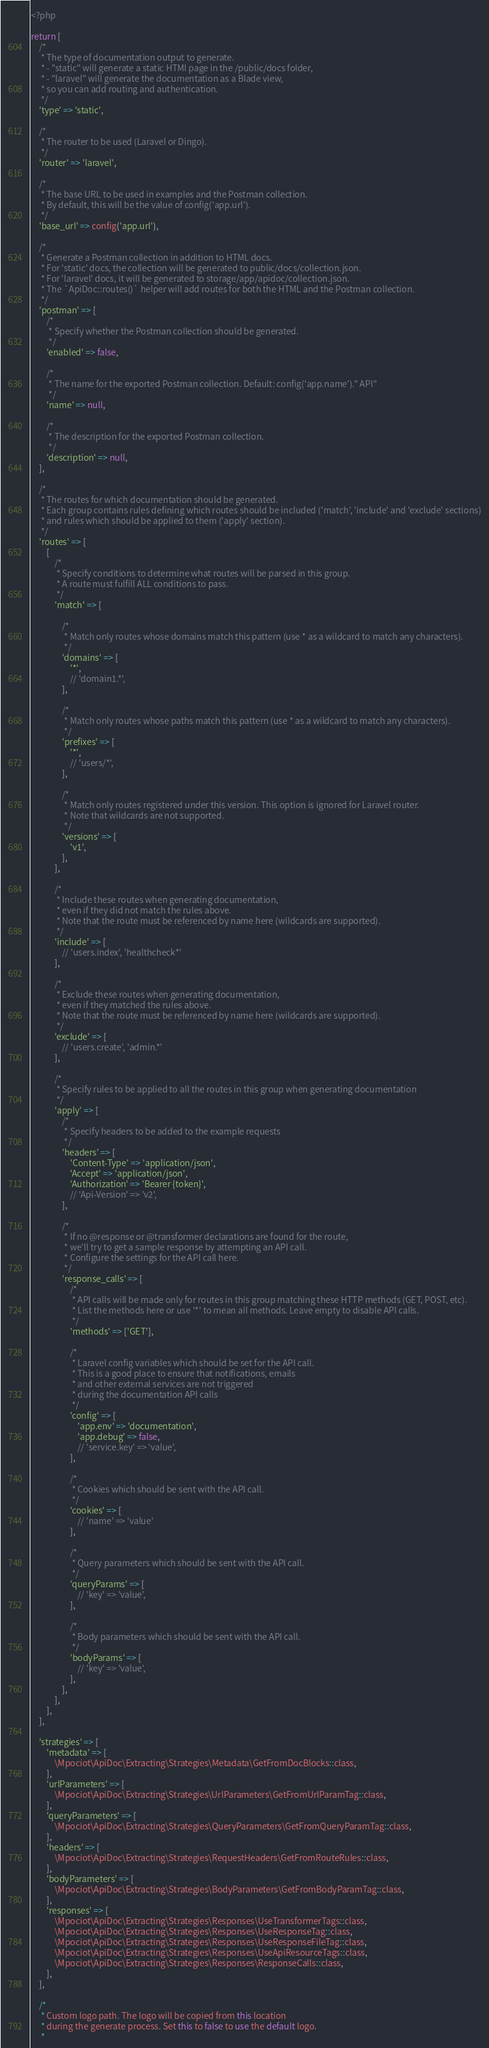<code> <loc_0><loc_0><loc_500><loc_500><_PHP_><?php

return [
    /*
     * The type of documentation output to generate.
     * - "static" will generate a static HTMl page in the /public/docs folder,
     * - "laravel" will generate the documentation as a Blade view,
     * so you can add routing and authentication.
     */
    'type' => 'static',

    /*
     * The router to be used (Laravel or Dingo).
     */
    'router' => 'laravel',

    /*
     * The base URL to be used in examples and the Postman collection.
     * By default, this will be the value of config('app.url').
     */
    'base_url' => config('app.url'),

    /*
     * Generate a Postman collection in addition to HTML docs.
     * For 'static' docs, the collection will be generated to public/docs/collection.json.
     * For 'laravel' docs, it will be generated to storage/app/apidoc/collection.json.
     * The `ApiDoc::routes()` helper will add routes for both the HTML and the Postman collection.
     */
    'postman' => [
        /*
         * Specify whether the Postman collection should be generated.
         */
        'enabled' => false,

        /*
         * The name for the exported Postman collection. Default: config('app.name')." API"
         */
        'name' => null,

        /*
         * The description for the exported Postman collection.
         */
        'description' => null,
    ],

    /*
     * The routes for which documentation should be generated.
     * Each group contains rules defining which routes should be included ('match', 'include' and 'exclude' sections)
     * and rules which should be applied to them ('apply' section).
     */
    'routes' => [
        [
            /*
             * Specify conditions to determine what routes will be parsed in this group.
             * A route must fulfill ALL conditions to pass.
             */
            'match' => [

                /*
                 * Match only routes whose domains match this pattern (use * as a wildcard to match any characters).
                 */
                'domains' => [
                    '*',
                    // 'domain1.*',
                ],

                /*
                 * Match only routes whose paths match this pattern (use * as a wildcard to match any characters).
                 */
                'prefixes' => [
                    '*',
                    // 'users/*',
                ],

                /*
                 * Match only routes registered under this version. This option is ignored for Laravel router.
                 * Note that wildcards are not supported.
                 */
                'versions' => [
                    'v1',
                ],
            ],

            /*
             * Include these routes when generating documentation,
             * even if they did not match the rules above.
             * Note that the route must be referenced by name here (wildcards are supported).
             */
            'include' => [
                // 'users.index', 'healthcheck*'
            ],

            /*
             * Exclude these routes when generating documentation,
             * even if they matched the rules above.
             * Note that the route must be referenced by name here (wildcards are supported).
             */
            'exclude' => [
                // 'users.create', 'admin.*'
            ],

            /*
             * Specify rules to be applied to all the routes in this group when generating documentation
             */
            'apply' => [
                /*
                 * Specify headers to be added to the example requests
                 */
                'headers' => [
                    'Content-Type' => 'application/json',
                    'Accept' => 'application/json',
                    'Authorization' => 'Bearer {token}',
                    // 'Api-Version' => 'v2',
                ],

                /*
                 * If no @response or @transformer declarations are found for the route,
                 * we'll try to get a sample response by attempting an API call.
                 * Configure the settings for the API call here.
                 */
                'response_calls' => [
                    /*
                     * API calls will be made only for routes in this group matching these HTTP methods (GET, POST, etc).
                     * List the methods here or use '*' to mean all methods. Leave empty to disable API calls.
                     */
                    'methods' => ['GET'],

                    /*
                     * Laravel config variables which should be set for the API call.
                     * This is a good place to ensure that notifications, emails
                     * and other external services are not triggered
                     * during the documentation API calls
                     */
                    'config' => [
                        'app.env' => 'documentation',
                        'app.debug' => false,
                        // 'service.key' => 'value',
                    ],

                    /*
                     * Cookies which should be sent with the API call.
                     */
                    'cookies' => [
                        // 'name' => 'value'
                    ],

                    /*
                     * Query parameters which should be sent with the API call.
                     */
                    'queryParams' => [
                        // 'key' => 'value',
                    ],

                    /*
                     * Body parameters which should be sent with the API call.
                     */
                    'bodyParams' => [
                        // 'key' => 'value',
                    ],
                ],
            ],
        ],
    ],

    'strategies' => [
        'metadata' => [
            \Mpociot\ApiDoc\Extracting\Strategies\Metadata\GetFromDocBlocks::class,
        ],
        'urlParameters' => [
            \Mpociot\ApiDoc\Extracting\Strategies\UrlParameters\GetFromUrlParamTag::class,
        ],
        'queryParameters' => [
            \Mpociot\ApiDoc\Extracting\Strategies\QueryParameters\GetFromQueryParamTag::class,
        ],
        'headers' => [
            \Mpociot\ApiDoc\Extracting\Strategies\RequestHeaders\GetFromRouteRules::class,
        ],
        'bodyParameters' => [
            \Mpociot\ApiDoc\Extracting\Strategies\BodyParameters\GetFromBodyParamTag::class,
        ],
        'responses' => [
            \Mpociot\ApiDoc\Extracting\Strategies\Responses\UseTransformerTags::class,
            \Mpociot\ApiDoc\Extracting\Strategies\Responses\UseResponseTag::class,
            \Mpociot\ApiDoc\Extracting\Strategies\Responses\UseResponseFileTag::class,
            \Mpociot\ApiDoc\Extracting\Strategies\Responses\UseApiResourceTags::class,
            \Mpociot\ApiDoc\Extracting\Strategies\Responses\ResponseCalls::class,
        ],
    ],

    /*
     * Custom logo path. The logo will be copied from this location
     * during the generate process. Set this to false to use the default logo.
     *</code> 